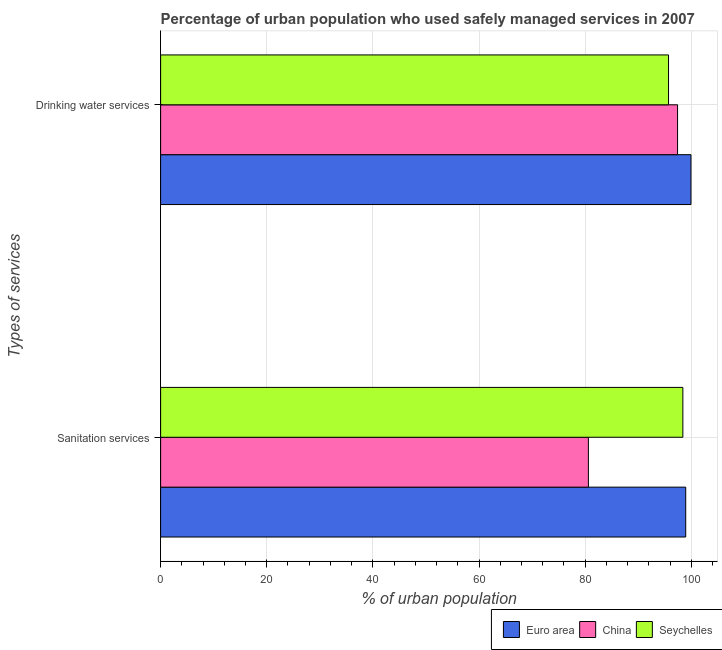How many groups of bars are there?
Offer a very short reply. 2. Are the number of bars per tick equal to the number of legend labels?
Your response must be concise. Yes. Are the number of bars on each tick of the Y-axis equal?
Give a very brief answer. Yes. How many bars are there on the 1st tick from the top?
Make the answer very short. 3. How many bars are there on the 2nd tick from the bottom?
Provide a succinct answer. 3. What is the label of the 1st group of bars from the top?
Ensure brevity in your answer.  Drinking water services. What is the percentage of urban population who used drinking water services in Seychelles?
Provide a short and direct response. 95.7. Across all countries, what is the maximum percentage of urban population who used drinking water services?
Ensure brevity in your answer.  99.93. Across all countries, what is the minimum percentage of urban population who used sanitation services?
Make the answer very short. 80.6. In which country was the percentage of urban population who used sanitation services maximum?
Your answer should be very brief. Euro area. In which country was the percentage of urban population who used drinking water services minimum?
Ensure brevity in your answer.  Seychelles. What is the total percentage of urban population who used sanitation services in the graph?
Your answer should be compact. 277.94. What is the difference between the percentage of urban population who used drinking water services in China and that in Seychelles?
Give a very brief answer. 1.7. What is the difference between the percentage of urban population who used sanitation services in Euro area and the percentage of urban population who used drinking water services in Seychelles?
Offer a terse response. 3.24. What is the average percentage of urban population who used drinking water services per country?
Ensure brevity in your answer.  97.68. What is the difference between the percentage of urban population who used sanitation services and percentage of urban population who used drinking water services in Seychelles?
Provide a short and direct response. 2.7. What is the ratio of the percentage of urban population who used sanitation services in Euro area to that in Seychelles?
Make the answer very short. 1.01. Is the percentage of urban population who used drinking water services in China less than that in Seychelles?
Your answer should be very brief. No. How many bars are there?
Ensure brevity in your answer.  6. Are all the bars in the graph horizontal?
Offer a terse response. Yes. How many countries are there in the graph?
Your answer should be very brief. 3. What is the difference between two consecutive major ticks on the X-axis?
Keep it short and to the point. 20. Are the values on the major ticks of X-axis written in scientific E-notation?
Ensure brevity in your answer.  No. How many legend labels are there?
Provide a short and direct response. 3. How are the legend labels stacked?
Offer a very short reply. Horizontal. What is the title of the graph?
Your response must be concise. Percentage of urban population who used safely managed services in 2007. Does "Cayman Islands" appear as one of the legend labels in the graph?
Keep it short and to the point. No. What is the label or title of the X-axis?
Ensure brevity in your answer.  % of urban population. What is the label or title of the Y-axis?
Provide a short and direct response. Types of services. What is the % of urban population of Euro area in Sanitation services?
Your answer should be very brief. 98.94. What is the % of urban population in China in Sanitation services?
Make the answer very short. 80.6. What is the % of urban population in Seychelles in Sanitation services?
Offer a very short reply. 98.4. What is the % of urban population in Euro area in Drinking water services?
Provide a succinct answer. 99.93. What is the % of urban population of China in Drinking water services?
Provide a short and direct response. 97.4. What is the % of urban population in Seychelles in Drinking water services?
Keep it short and to the point. 95.7. Across all Types of services, what is the maximum % of urban population of Euro area?
Ensure brevity in your answer.  99.93. Across all Types of services, what is the maximum % of urban population in China?
Provide a succinct answer. 97.4. Across all Types of services, what is the maximum % of urban population of Seychelles?
Offer a terse response. 98.4. Across all Types of services, what is the minimum % of urban population of Euro area?
Provide a succinct answer. 98.94. Across all Types of services, what is the minimum % of urban population of China?
Offer a very short reply. 80.6. Across all Types of services, what is the minimum % of urban population of Seychelles?
Your response must be concise. 95.7. What is the total % of urban population of Euro area in the graph?
Make the answer very short. 198.87. What is the total % of urban population in China in the graph?
Offer a terse response. 178. What is the total % of urban population of Seychelles in the graph?
Offer a very short reply. 194.1. What is the difference between the % of urban population in Euro area in Sanitation services and that in Drinking water services?
Your response must be concise. -0.99. What is the difference between the % of urban population in China in Sanitation services and that in Drinking water services?
Your response must be concise. -16.8. What is the difference between the % of urban population of Seychelles in Sanitation services and that in Drinking water services?
Ensure brevity in your answer.  2.7. What is the difference between the % of urban population of Euro area in Sanitation services and the % of urban population of China in Drinking water services?
Provide a succinct answer. 1.54. What is the difference between the % of urban population of Euro area in Sanitation services and the % of urban population of Seychelles in Drinking water services?
Provide a short and direct response. 3.24. What is the difference between the % of urban population of China in Sanitation services and the % of urban population of Seychelles in Drinking water services?
Your answer should be very brief. -15.1. What is the average % of urban population of Euro area per Types of services?
Your answer should be compact. 99.43. What is the average % of urban population of China per Types of services?
Your answer should be compact. 89. What is the average % of urban population of Seychelles per Types of services?
Your response must be concise. 97.05. What is the difference between the % of urban population in Euro area and % of urban population in China in Sanitation services?
Make the answer very short. 18.34. What is the difference between the % of urban population in Euro area and % of urban population in Seychelles in Sanitation services?
Keep it short and to the point. 0.54. What is the difference between the % of urban population of China and % of urban population of Seychelles in Sanitation services?
Your answer should be compact. -17.8. What is the difference between the % of urban population in Euro area and % of urban population in China in Drinking water services?
Offer a very short reply. 2.53. What is the difference between the % of urban population of Euro area and % of urban population of Seychelles in Drinking water services?
Your response must be concise. 4.23. What is the difference between the % of urban population of China and % of urban population of Seychelles in Drinking water services?
Ensure brevity in your answer.  1.7. What is the ratio of the % of urban population in China in Sanitation services to that in Drinking water services?
Your answer should be compact. 0.83. What is the ratio of the % of urban population of Seychelles in Sanitation services to that in Drinking water services?
Offer a very short reply. 1.03. What is the difference between the highest and the second highest % of urban population of Euro area?
Your answer should be compact. 0.99. What is the difference between the highest and the lowest % of urban population of Euro area?
Provide a short and direct response. 0.99. What is the difference between the highest and the lowest % of urban population of Seychelles?
Keep it short and to the point. 2.7. 